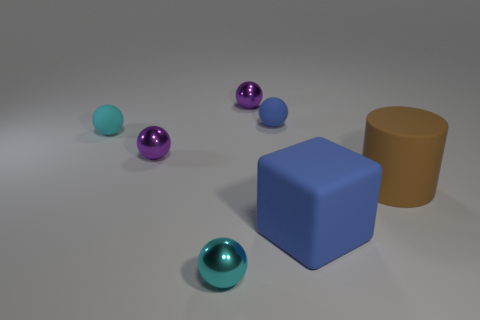Which objects are closest to the large brown cylinder? The closest objects to the large brown cylinder are the large blue cube and the small teal rubber sphere. They are positioned on opposite sides of the cylinder. 